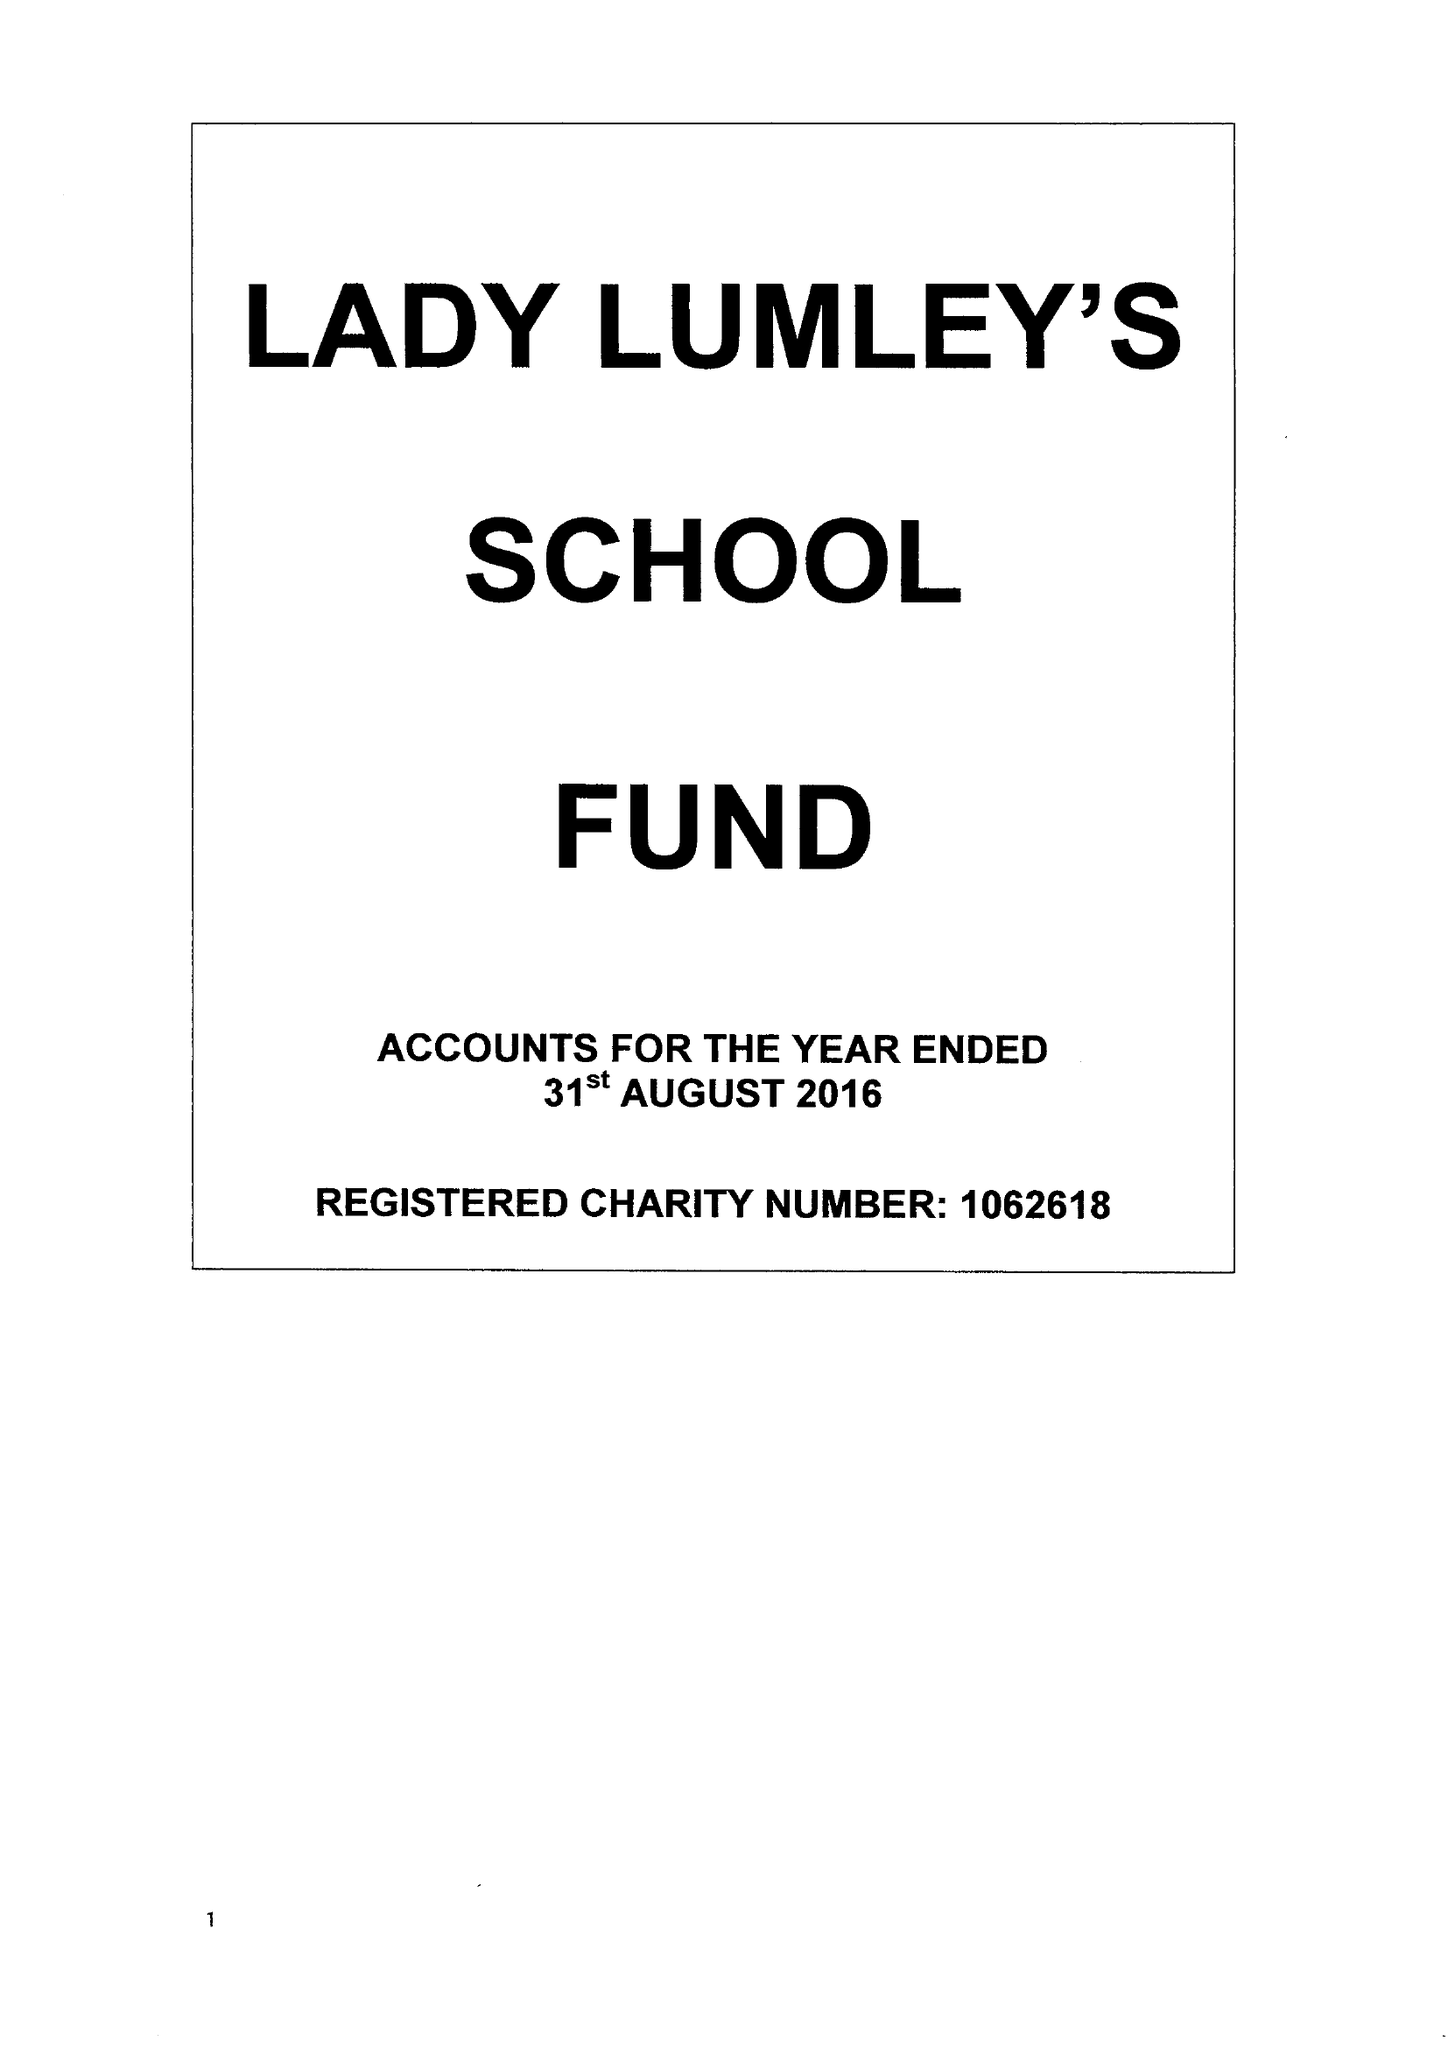What is the value for the income_annually_in_british_pounds?
Answer the question using a single word or phrase. 161374.00 